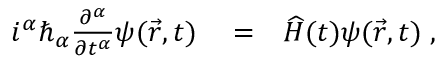<formula> <loc_0><loc_0><loc_500><loc_500>\begin{array} { r l r } { i ^ { \alpha } \hbar { _ } { \alpha } \frac { \partial ^ { \alpha } } { \partial t ^ { \alpha } } \psi ( \vec { r } , t ) } & = } & { \widehat { H } ( t ) \psi ( \vec { r } , t ) \, , } \end{array}</formula> 